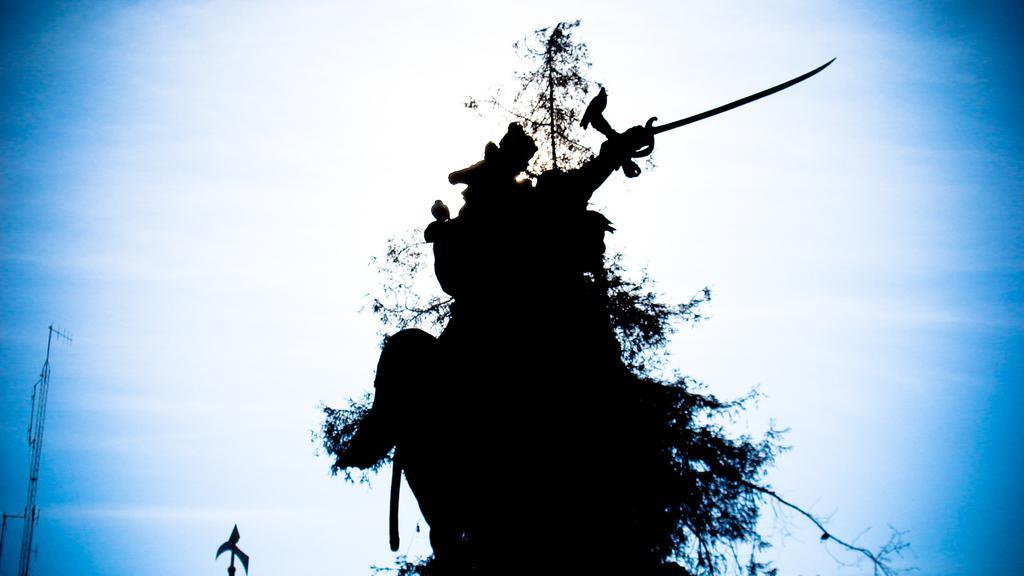Can you describe this image briefly? This is an art. In which, we can see there are birds on a tree. In the background, there is a tower and there are clouds in the sky. 